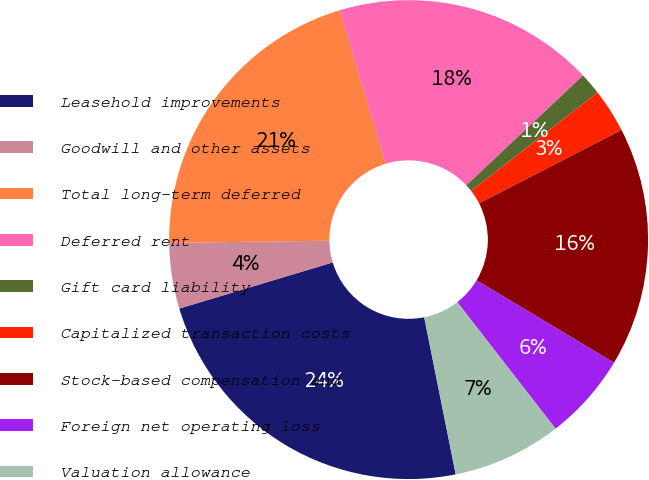<chart> <loc_0><loc_0><loc_500><loc_500><pie_chart><fcel>Leasehold improvements<fcel>Goodwill and other assets<fcel>Total long-term deferred<fcel>Deferred rent<fcel>Gift card liability<fcel>Capitalized transaction costs<fcel>Stock-based compensation and<fcel>Foreign net operating loss<fcel>Valuation allowance<nl><fcel>23.5%<fcel>4.43%<fcel>20.57%<fcel>17.63%<fcel>1.49%<fcel>2.96%<fcel>16.16%<fcel>5.89%<fcel>7.36%<nl></chart> 